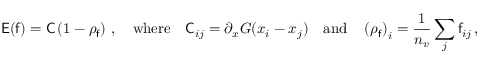Convert formula to latex. <formula><loc_0><loc_0><loc_500><loc_500>E ( f ) = C \left ( 1 - \rho _ { f } \right ) \, , \quad w h e r e \quad C _ { i j } = \partial _ { x } G ( x _ { i } - x _ { j } ) \quad a n d \quad \left ( \rho _ { f } \right ) _ { i } = \frac { 1 } { n _ { v } } \sum _ { j } f _ { i j } \, ,</formula> 